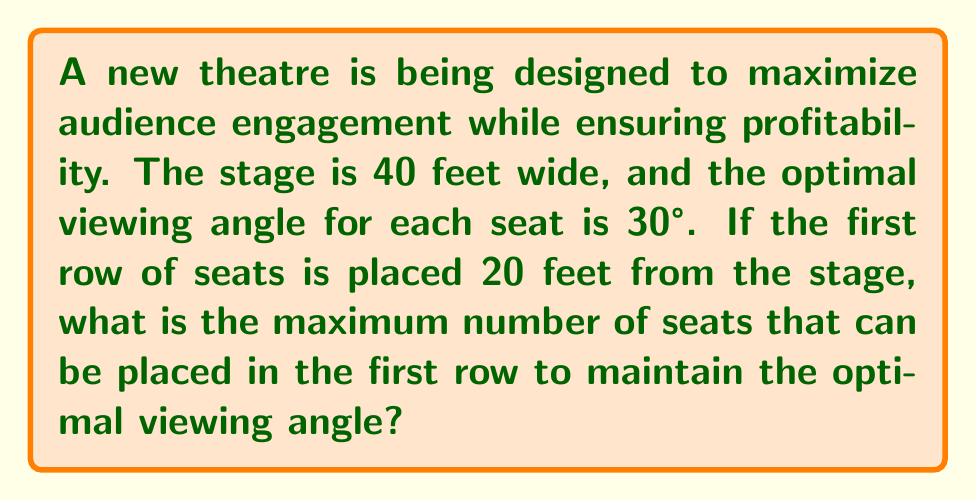What is the answer to this math problem? Let's approach this step-by-step:

1) First, we need to visualize the problem. The optimal viewing angle forms an isosceles triangle with the stage as the base.

2) Let's draw a line perpendicular to the stage at its midpoint. This line bisects the viewing angle and creates two right triangles.

3) In one of these right triangles:
   - The adjacent side is half the stage width: $20$ feet
   - The hypotenuse is the distance from the seat to the edge of the stage
   - The angle between these is half of 30°, which is 15°

4) We can use the tangent function to find the width of the seating area:

   $$\tan(15°) = \frac{20}{\text{distance from center}}$$

5) Rearranging this equation:

   $$\text{distance from center} = \frac{20}{\tan(15°)}$$

6) Calculate this value:

   $$\text{distance from center} \approx 74.64 \text{ feet}$$

7) The total width of the seating area is twice this:

   $$\text{Total width} \approx 2 * 74.64 = 149.28 \text{ feet}$$

8) Assuming each seat is 2 feet wide (a typical theatre seat width), we can calculate the maximum number of seats:

   $$\text{Number of seats} = \frac{149.28}{2} \approx 74.64$$

9) Since we can't have a fractional seat, we round down to 74 seats.
Answer: 74 seats 